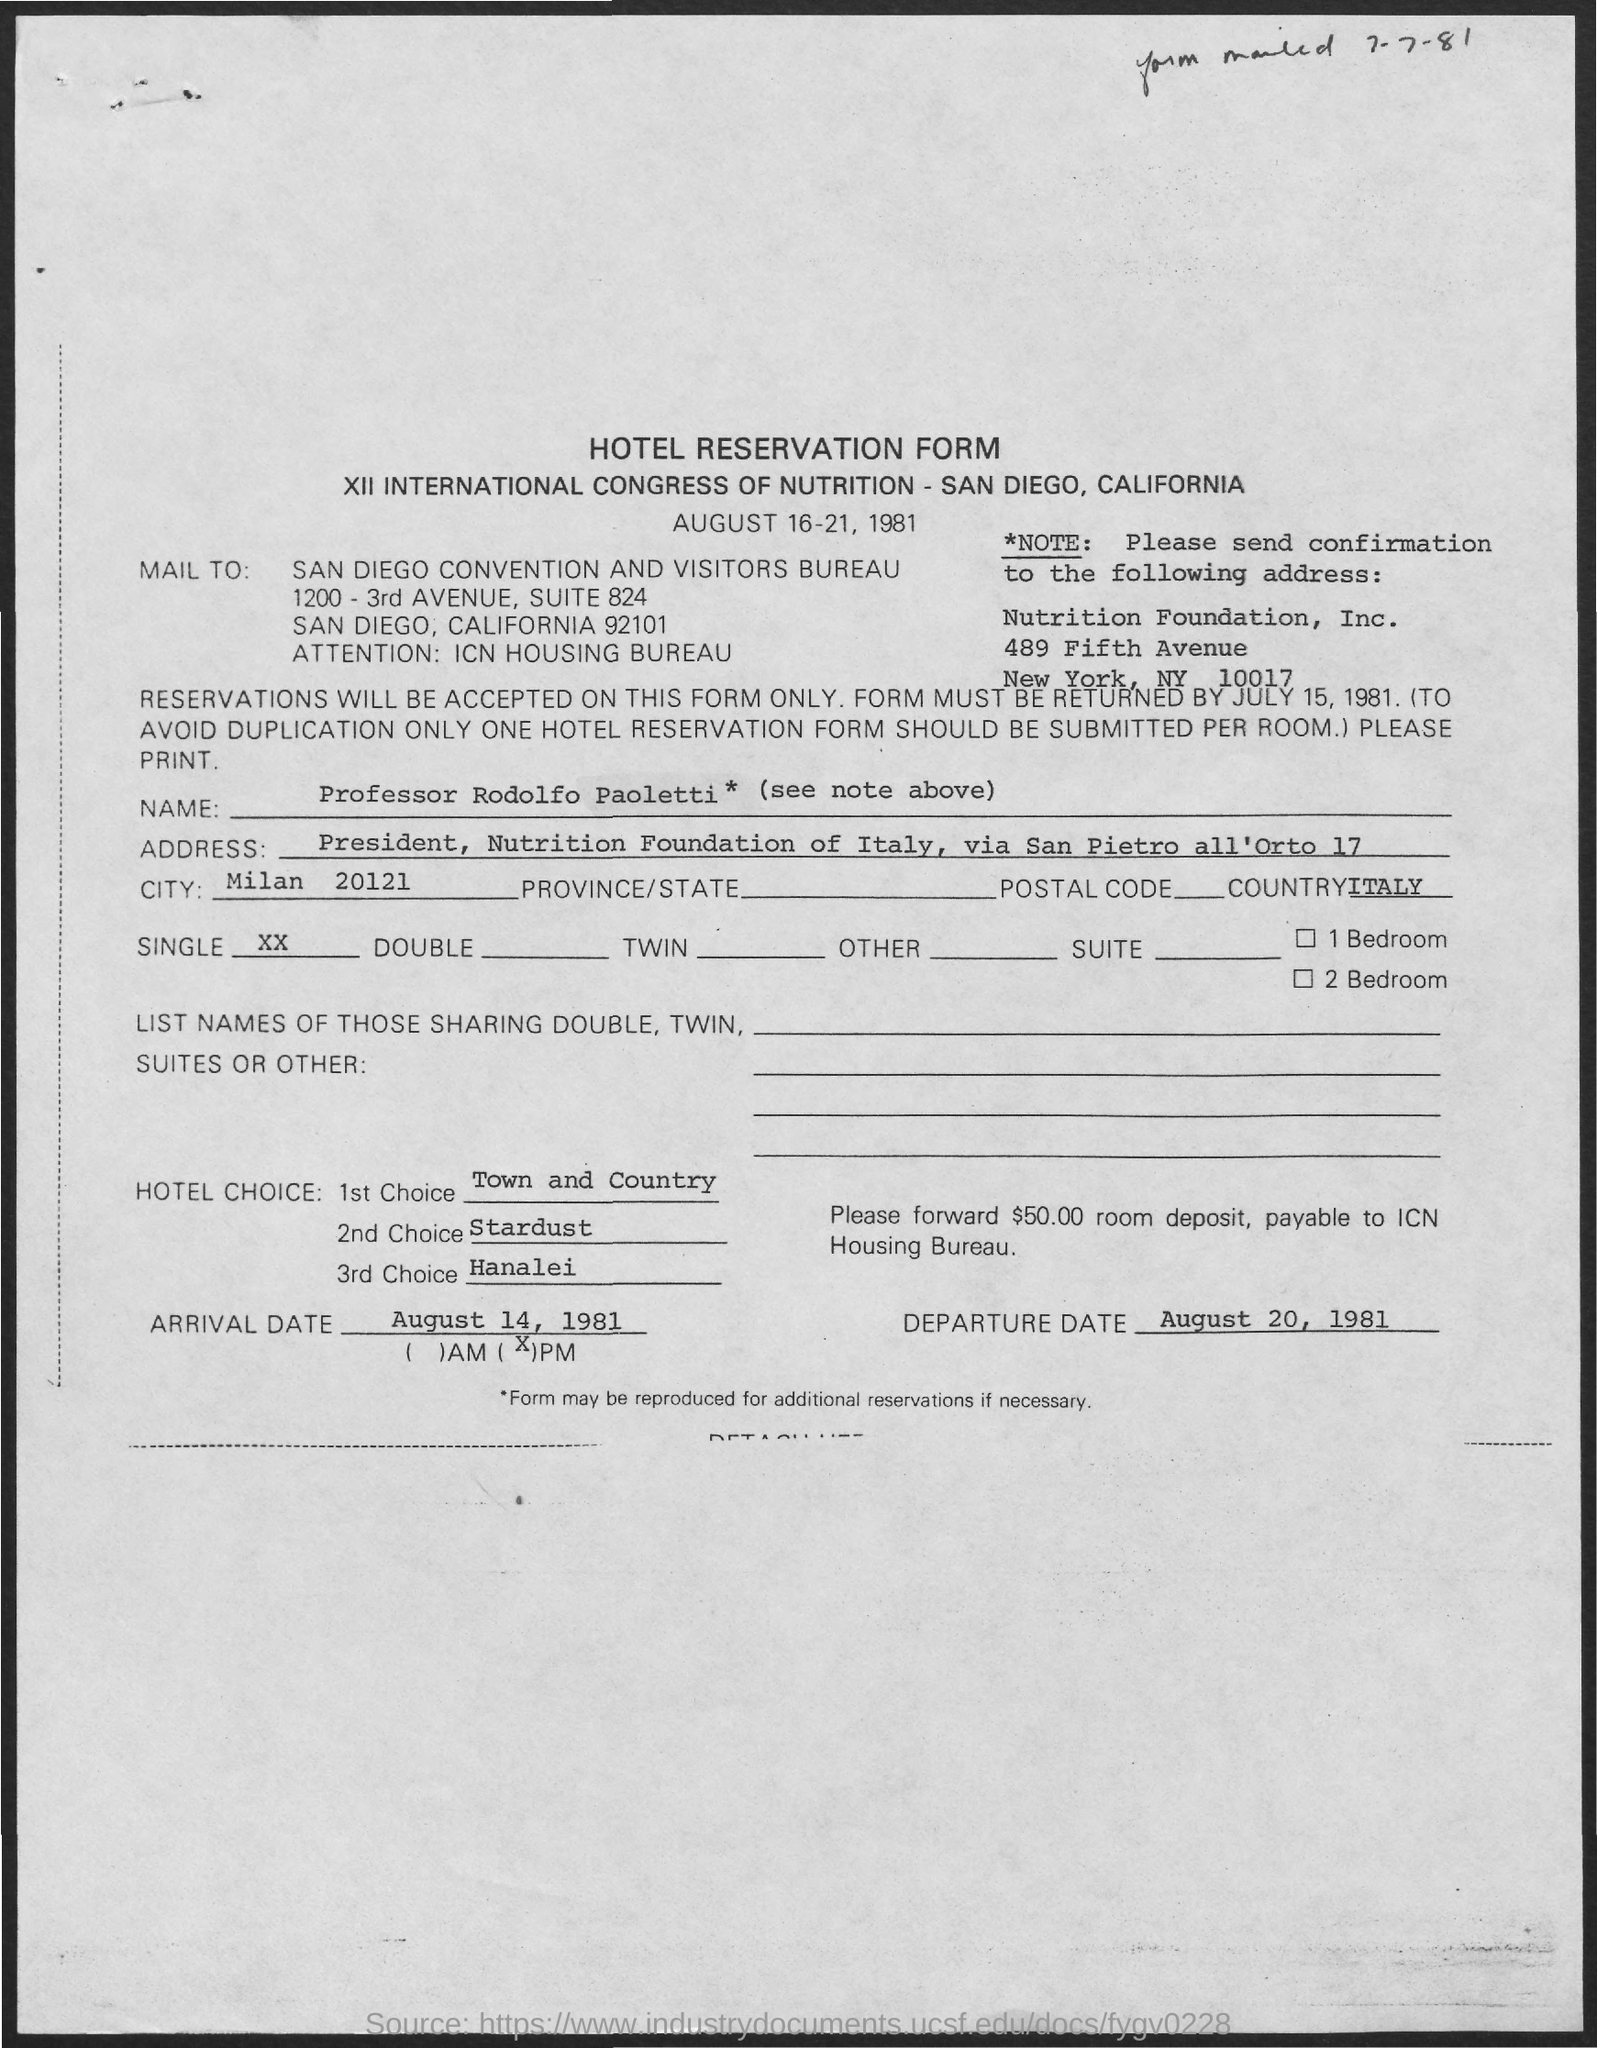What is the form given in the page ?
Give a very brief answer. Hotel reservation form. To whom this has to be mailed ?
Ensure brevity in your answer.  San diego convention and visitors bureau. Who's name was written in the hotel reservation form ?
Make the answer very short. Professor rodolfo paoletti. What is the name of the country mentioned in the hotel reservation form ?
Provide a short and direct response. Italy. What is the arrival date mentioned in the given reservation form ?
Give a very brief answer. August 14, 1981. What is the departure date mentioned in the given reservation form ?
Provide a short and direct response. August 20 , 1981. What is the 1st hotel choice mentioned in the reservation form ?
Provide a succinct answer. Town and country. What is the 2nd hotel choice mentioned in the reservation form ?
Ensure brevity in your answer.  Stardust. What is the 3rd hotel choice mentioned in the reservation form ?
Provide a succinct answer. Hanalei. 